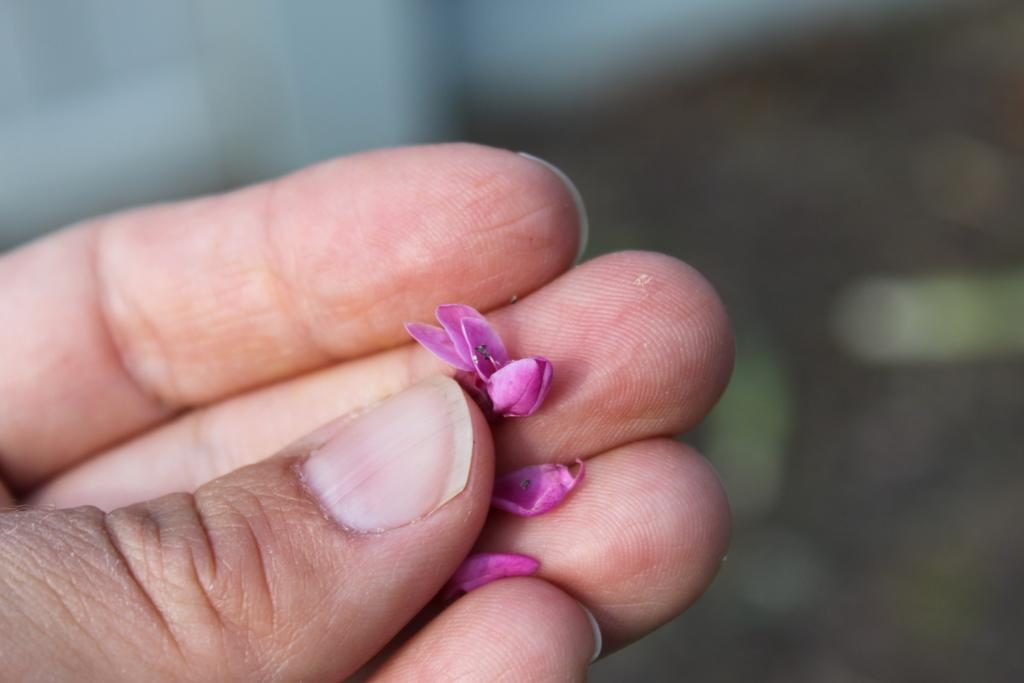Who or what is the main subject in the image? There is a person in the image. What is the person holding in the image? The person is holding a pink flower and petals. Can you describe the background of the image? The background of the image is blurry. How many people are in the crowd in the image? There is no crowd present in the image; it features a single person holding a pink flower and petals. What fact can be learned about the table in the image? There is no table present in the image. 